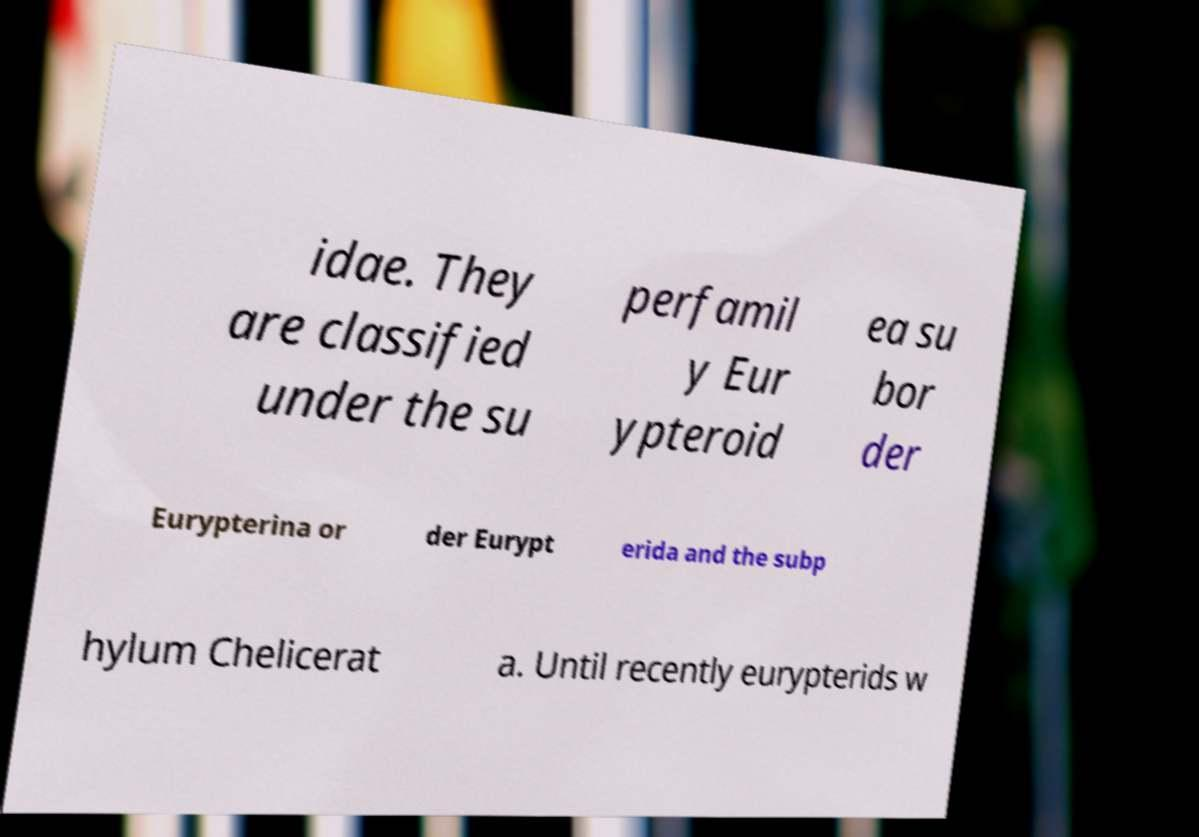Can you read and provide the text displayed in the image?This photo seems to have some interesting text. Can you extract and type it out for me? idae. They are classified under the su perfamil y Eur ypteroid ea su bor der Eurypterina or der Eurypt erida and the subp hylum Chelicerat a. Until recently eurypterids w 